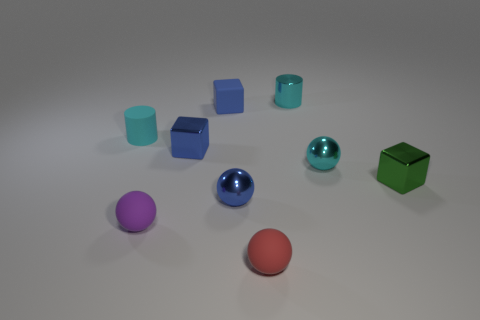Add 1 small yellow matte cylinders. How many objects exist? 10 Subtract all balls. How many objects are left? 5 Subtract all tiny blue metallic things. Subtract all small blue cubes. How many objects are left? 5 Add 8 small green cubes. How many small green cubes are left? 9 Add 3 purple matte objects. How many purple matte objects exist? 4 Subtract 0 red cubes. How many objects are left? 9 